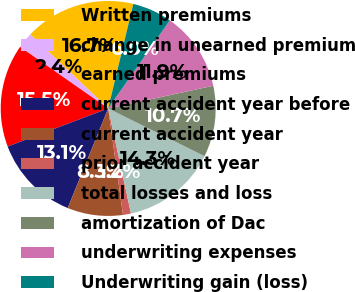Convert chart. <chart><loc_0><loc_0><loc_500><loc_500><pie_chart><fcel>Written premiums<fcel>change in unearned premium<fcel>earned premiums<fcel>current accident year before<fcel>current accident year<fcel>prior accident year<fcel>total losses and loss<fcel>amortization of Dac<fcel>underwriting expenses<fcel>Underwriting gain (loss)<nl><fcel>16.66%<fcel>2.39%<fcel>15.47%<fcel>13.09%<fcel>8.34%<fcel>1.2%<fcel>14.28%<fcel>10.71%<fcel>11.9%<fcel>5.96%<nl></chart> 